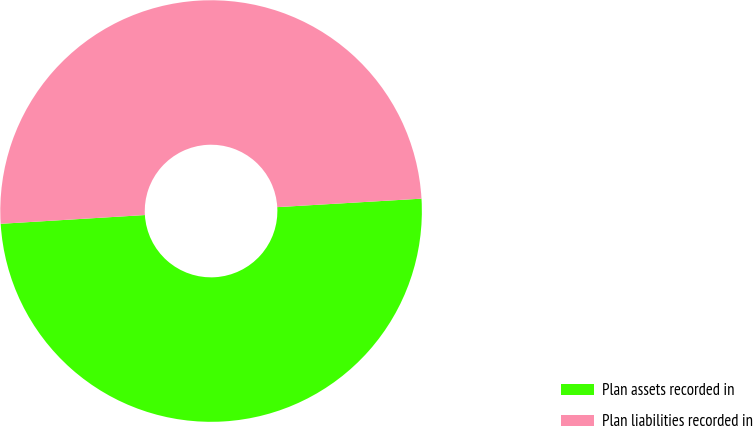Convert chart. <chart><loc_0><loc_0><loc_500><loc_500><pie_chart><fcel>Plan assets recorded in<fcel>Plan liabilities recorded in<nl><fcel>49.97%<fcel>50.03%<nl></chart> 